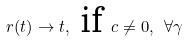Convert formula to latex. <formula><loc_0><loc_0><loc_500><loc_500>r ( t ) \rightarrow t , \text { if } c \neq 0 , \text { } \forall \gamma</formula> 